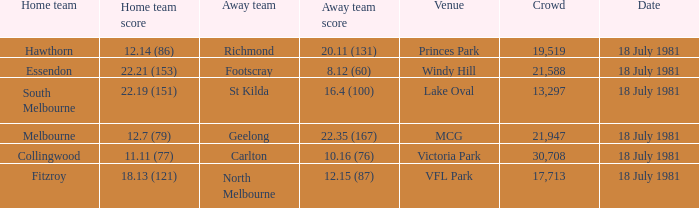On what date was the Essendon home match? 18 July 1981. 